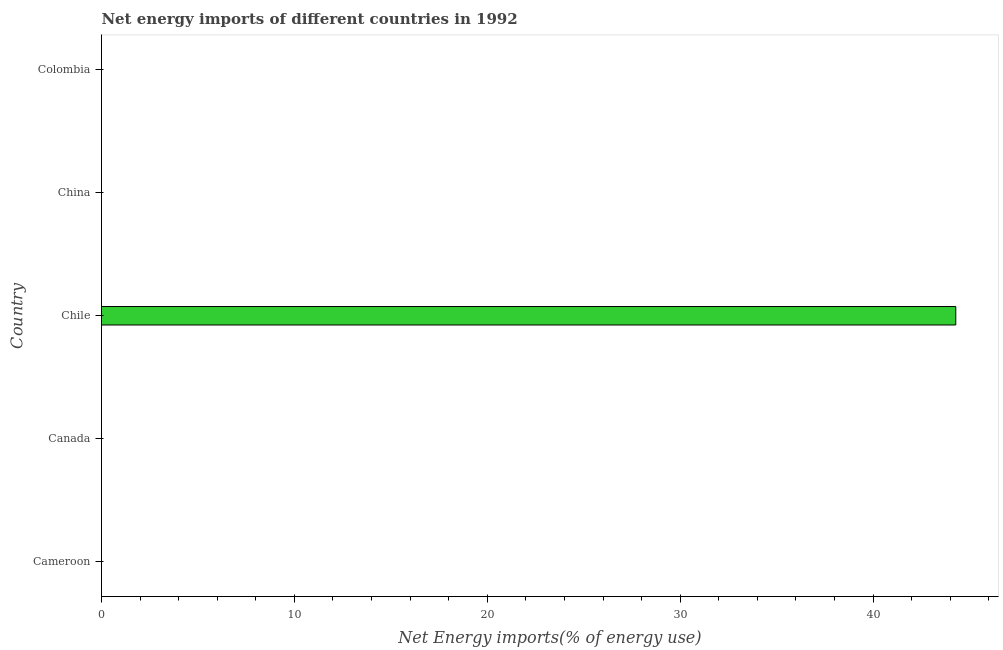Does the graph contain any zero values?
Offer a very short reply. Yes. What is the title of the graph?
Your response must be concise. Net energy imports of different countries in 1992. What is the label or title of the X-axis?
Provide a succinct answer. Net Energy imports(% of energy use). Across all countries, what is the maximum energy imports?
Provide a short and direct response. 44.29. In which country was the energy imports maximum?
Ensure brevity in your answer.  Chile. What is the sum of the energy imports?
Provide a succinct answer. 44.29. What is the average energy imports per country?
Give a very brief answer. 8.86. In how many countries, is the energy imports greater than 40 %?
Provide a short and direct response. 1. What is the difference between the highest and the lowest energy imports?
Give a very brief answer. 44.29. In how many countries, is the energy imports greater than the average energy imports taken over all countries?
Provide a short and direct response. 1. How many countries are there in the graph?
Ensure brevity in your answer.  5. Are the values on the major ticks of X-axis written in scientific E-notation?
Your answer should be very brief. No. What is the Net Energy imports(% of energy use) in Cameroon?
Make the answer very short. 0. What is the Net Energy imports(% of energy use) of Chile?
Make the answer very short. 44.29. 